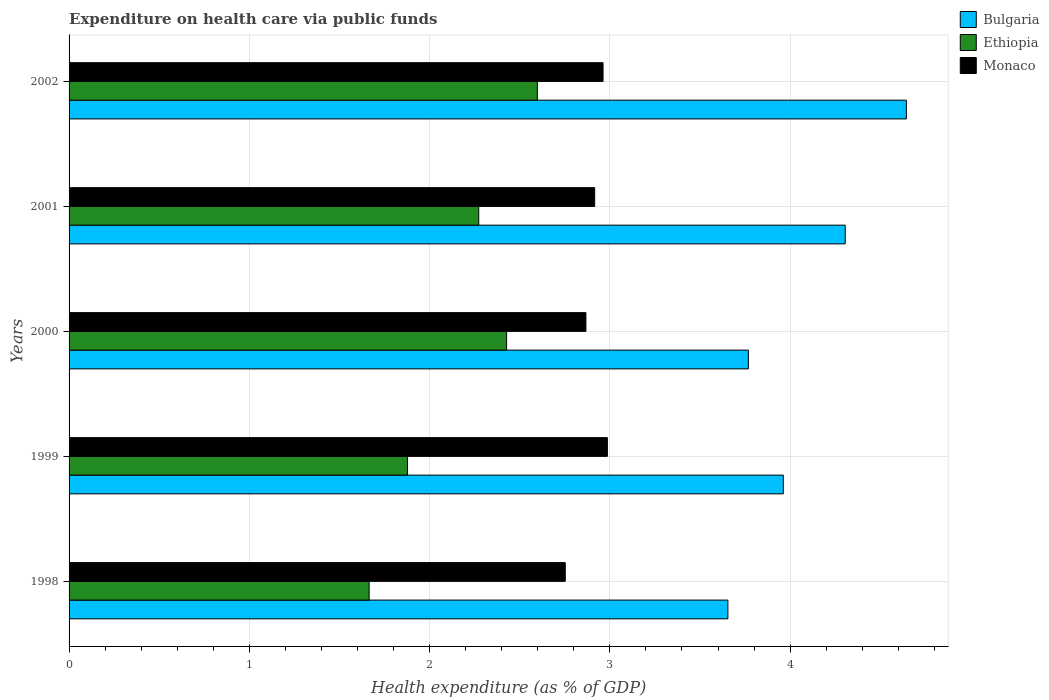How many groups of bars are there?
Offer a terse response. 5. Are the number of bars per tick equal to the number of legend labels?
Offer a terse response. Yes. Are the number of bars on each tick of the Y-axis equal?
Your response must be concise. Yes. How many bars are there on the 3rd tick from the top?
Ensure brevity in your answer.  3. In how many cases, is the number of bars for a given year not equal to the number of legend labels?
Give a very brief answer. 0. What is the expenditure made on health care in Ethiopia in 2002?
Provide a short and direct response. 2.6. Across all years, what is the maximum expenditure made on health care in Monaco?
Offer a very short reply. 2.99. Across all years, what is the minimum expenditure made on health care in Bulgaria?
Offer a terse response. 3.65. In which year was the expenditure made on health care in Bulgaria maximum?
Your response must be concise. 2002. In which year was the expenditure made on health care in Monaco minimum?
Provide a succinct answer. 1998. What is the total expenditure made on health care in Monaco in the graph?
Offer a very short reply. 14.48. What is the difference between the expenditure made on health care in Bulgaria in 2000 and that in 2001?
Your response must be concise. -0.54. What is the difference between the expenditure made on health care in Bulgaria in 2001 and the expenditure made on health care in Ethiopia in 2002?
Make the answer very short. 1.71. What is the average expenditure made on health care in Ethiopia per year?
Your answer should be very brief. 2.17. In the year 1999, what is the difference between the expenditure made on health care in Monaco and expenditure made on health care in Ethiopia?
Give a very brief answer. 1.11. What is the ratio of the expenditure made on health care in Ethiopia in 1998 to that in 2001?
Your answer should be compact. 0.73. Is the expenditure made on health care in Ethiopia in 1998 less than that in 1999?
Keep it short and to the point. Yes. What is the difference between the highest and the second highest expenditure made on health care in Monaco?
Keep it short and to the point. 0.02. What is the difference between the highest and the lowest expenditure made on health care in Bulgaria?
Provide a short and direct response. 0.99. In how many years, is the expenditure made on health care in Monaco greater than the average expenditure made on health care in Monaco taken over all years?
Provide a short and direct response. 3. What does the 1st bar from the top in 2000 represents?
Offer a very short reply. Monaco. What does the 1st bar from the bottom in 1998 represents?
Your response must be concise. Bulgaria. Are all the bars in the graph horizontal?
Offer a very short reply. Yes. Are the values on the major ticks of X-axis written in scientific E-notation?
Keep it short and to the point. No. Does the graph contain any zero values?
Offer a very short reply. No. Where does the legend appear in the graph?
Provide a succinct answer. Top right. What is the title of the graph?
Keep it short and to the point. Expenditure on health care via public funds. Does "Lao PDR" appear as one of the legend labels in the graph?
Your answer should be very brief. No. What is the label or title of the X-axis?
Keep it short and to the point. Health expenditure (as % of GDP). What is the label or title of the Y-axis?
Keep it short and to the point. Years. What is the Health expenditure (as % of GDP) in Bulgaria in 1998?
Make the answer very short. 3.65. What is the Health expenditure (as % of GDP) of Ethiopia in 1998?
Ensure brevity in your answer.  1.66. What is the Health expenditure (as % of GDP) in Monaco in 1998?
Your answer should be compact. 2.75. What is the Health expenditure (as % of GDP) of Bulgaria in 1999?
Your response must be concise. 3.96. What is the Health expenditure (as % of GDP) of Ethiopia in 1999?
Make the answer very short. 1.88. What is the Health expenditure (as % of GDP) in Monaco in 1999?
Ensure brevity in your answer.  2.99. What is the Health expenditure (as % of GDP) in Bulgaria in 2000?
Ensure brevity in your answer.  3.77. What is the Health expenditure (as % of GDP) in Ethiopia in 2000?
Your answer should be compact. 2.43. What is the Health expenditure (as % of GDP) of Monaco in 2000?
Your answer should be compact. 2.87. What is the Health expenditure (as % of GDP) of Bulgaria in 2001?
Your answer should be compact. 4.31. What is the Health expenditure (as % of GDP) of Ethiopia in 2001?
Provide a succinct answer. 2.27. What is the Health expenditure (as % of GDP) of Monaco in 2001?
Make the answer very short. 2.92. What is the Health expenditure (as % of GDP) in Bulgaria in 2002?
Keep it short and to the point. 4.65. What is the Health expenditure (as % of GDP) of Ethiopia in 2002?
Your answer should be very brief. 2.6. What is the Health expenditure (as % of GDP) of Monaco in 2002?
Give a very brief answer. 2.96. Across all years, what is the maximum Health expenditure (as % of GDP) of Bulgaria?
Keep it short and to the point. 4.65. Across all years, what is the maximum Health expenditure (as % of GDP) of Ethiopia?
Offer a very short reply. 2.6. Across all years, what is the maximum Health expenditure (as % of GDP) of Monaco?
Your answer should be very brief. 2.99. Across all years, what is the minimum Health expenditure (as % of GDP) in Bulgaria?
Offer a very short reply. 3.65. Across all years, what is the minimum Health expenditure (as % of GDP) in Ethiopia?
Make the answer very short. 1.66. Across all years, what is the minimum Health expenditure (as % of GDP) in Monaco?
Your answer should be very brief. 2.75. What is the total Health expenditure (as % of GDP) in Bulgaria in the graph?
Make the answer very short. 20.34. What is the total Health expenditure (as % of GDP) in Ethiopia in the graph?
Your answer should be very brief. 10.84. What is the total Health expenditure (as % of GDP) in Monaco in the graph?
Make the answer very short. 14.48. What is the difference between the Health expenditure (as % of GDP) in Bulgaria in 1998 and that in 1999?
Provide a succinct answer. -0.31. What is the difference between the Health expenditure (as % of GDP) in Ethiopia in 1998 and that in 1999?
Provide a succinct answer. -0.21. What is the difference between the Health expenditure (as % of GDP) in Monaco in 1998 and that in 1999?
Provide a succinct answer. -0.23. What is the difference between the Health expenditure (as % of GDP) in Bulgaria in 1998 and that in 2000?
Offer a very short reply. -0.11. What is the difference between the Health expenditure (as % of GDP) of Ethiopia in 1998 and that in 2000?
Your answer should be very brief. -0.76. What is the difference between the Health expenditure (as % of GDP) of Monaco in 1998 and that in 2000?
Your answer should be very brief. -0.11. What is the difference between the Health expenditure (as % of GDP) in Bulgaria in 1998 and that in 2001?
Offer a terse response. -0.65. What is the difference between the Health expenditure (as % of GDP) of Ethiopia in 1998 and that in 2001?
Offer a very short reply. -0.61. What is the difference between the Health expenditure (as % of GDP) in Monaco in 1998 and that in 2001?
Offer a terse response. -0.16. What is the difference between the Health expenditure (as % of GDP) in Bulgaria in 1998 and that in 2002?
Offer a terse response. -0.99. What is the difference between the Health expenditure (as % of GDP) of Ethiopia in 1998 and that in 2002?
Make the answer very short. -0.93. What is the difference between the Health expenditure (as % of GDP) of Monaco in 1998 and that in 2002?
Offer a very short reply. -0.21. What is the difference between the Health expenditure (as % of GDP) of Bulgaria in 1999 and that in 2000?
Give a very brief answer. 0.19. What is the difference between the Health expenditure (as % of GDP) of Ethiopia in 1999 and that in 2000?
Ensure brevity in your answer.  -0.55. What is the difference between the Health expenditure (as % of GDP) of Monaco in 1999 and that in 2000?
Your answer should be very brief. 0.12. What is the difference between the Health expenditure (as % of GDP) in Bulgaria in 1999 and that in 2001?
Offer a very short reply. -0.34. What is the difference between the Health expenditure (as % of GDP) in Ethiopia in 1999 and that in 2001?
Provide a succinct answer. -0.4. What is the difference between the Health expenditure (as % of GDP) of Monaco in 1999 and that in 2001?
Your answer should be compact. 0.07. What is the difference between the Health expenditure (as % of GDP) of Bulgaria in 1999 and that in 2002?
Provide a short and direct response. -0.68. What is the difference between the Health expenditure (as % of GDP) in Ethiopia in 1999 and that in 2002?
Your answer should be compact. -0.72. What is the difference between the Health expenditure (as % of GDP) of Monaco in 1999 and that in 2002?
Ensure brevity in your answer.  0.02. What is the difference between the Health expenditure (as % of GDP) of Bulgaria in 2000 and that in 2001?
Provide a short and direct response. -0.54. What is the difference between the Health expenditure (as % of GDP) in Ethiopia in 2000 and that in 2001?
Provide a short and direct response. 0.15. What is the difference between the Health expenditure (as % of GDP) of Monaco in 2000 and that in 2001?
Your answer should be compact. -0.05. What is the difference between the Health expenditure (as % of GDP) in Bulgaria in 2000 and that in 2002?
Your answer should be compact. -0.88. What is the difference between the Health expenditure (as % of GDP) of Ethiopia in 2000 and that in 2002?
Your response must be concise. -0.17. What is the difference between the Health expenditure (as % of GDP) in Monaco in 2000 and that in 2002?
Give a very brief answer. -0.1. What is the difference between the Health expenditure (as % of GDP) of Bulgaria in 2001 and that in 2002?
Your answer should be very brief. -0.34. What is the difference between the Health expenditure (as % of GDP) in Ethiopia in 2001 and that in 2002?
Offer a terse response. -0.33. What is the difference between the Health expenditure (as % of GDP) of Monaco in 2001 and that in 2002?
Make the answer very short. -0.05. What is the difference between the Health expenditure (as % of GDP) in Bulgaria in 1998 and the Health expenditure (as % of GDP) in Ethiopia in 1999?
Give a very brief answer. 1.78. What is the difference between the Health expenditure (as % of GDP) of Bulgaria in 1998 and the Health expenditure (as % of GDP) of Monaco in 1999?
Keep it short and to the point. 0.67. What is the difference between the Health expenditure (as % of GDP) of Ethiopia in 1998 and the Health expenditure (as % of GDP) of Monaco in 1999?
Your response must be concise. -1.32. What is the difference between the Health expenditure (as % of GDP) of Bulgaria in 1998 and the Health expenditure (as % of GDP) of Ethiopia in 2000?
Make the answer very short. 1.23. What is the difference between the Health expenditure (as % of GDP) in Bulgaria in 1998 and the Health expenditure (as % of GDP) in Monaco in 2000?
Your answer should be compact. 0.79. What is the difference between the Health expenditure (as % of GDP) of Ethiopia in 1998 and the Health expenditure (as % of GDP) of Monaco in 2000?
Your response must be concise. -1.2. What is the difference between the Health expenditure (as % of GDP) in Bulgaria in 1998 and the Health expenditure (as % of GDP) in Ethiopia in 2001?
Ensure brevity in your answer.  1.38. What is the difference between the Health expenditure (as % of GDP) of Bulgaria in 1998 and the Health expenditure (as % of GDP) of Monaco in 2001?
Your answer should be very brief. 0.74. What is the difference between the Health expenditure (as % of GDP) in Ethiopia in 1998 and the Health expenditure (as % of GDP) in Monaco in 2001?
Provide a succinct answer. -1.25. What is the difference between the Health expenditure (as % of GDP) of Bulgaria in 1998 and the Health expenditure (as % of GDP) of Ethiopia in 2002?
Your answer should be very brief. 1.06. What is the difference between the Health expenditure (as % of GDP) in Bulgaria in 1998 and the Health expenditure (as % of GDP) in Monaco in 2002?
Make the answer very short. 0.69. What is the difference between the Health expenditure (as % of GDP) in Ethiopia in 1998 and the Health expenditure (as % of GDP) in Monaco in 2002?
Offer a very short reply. -1.3. What is the difference between the Health expenditure (as % of GDP) of Bulgaria in 1999 and the Health expenditure (as % of GDP) of Ethiopia in 2000?
Keep it short and to the point. 1.54. What is the difference between the Health expenditure (as % of GDP) of Bulgaria in 1999 and the Health expenditure (as % of GDP) of Monaco in 2000?
Your answer should be very brief. 1.1. What is the difference between the Health expenditure (as % of GDP) in Ethiopia in 1999 and the Health expenditure (as % of GDP) in Monaco in 2000?
Your response must be concise. -0.99. What is the difference between the Health expenditure (as % of GDP) in Bulgaria in 1999 and the Health expenditure (as % of GDP) in Ethiopia in 2001?
Make the answer very short. 1.69. What is the difference between the Health expenditure (as % of GDP) in Bulgaria in 1999 and the Health expenditure (as % of GDP) in Monaco in 2001?
Offer a very short reply. 1.05. What is the difference between the Health expenditure (as % of GDP) of Ethiopia in 1999 and the Health expenditure (as % of GDP) of Monaco in 2001?
Your answer should be compact. -1.04. What is the difference between the Health expenditure (as % of GDP) in Bulgaria in 1999 and the Health expenditure (as % of GDP) in Ethiopia in 2002?
Your answer should be very brief. 1.36. What is the difference between the Health expenditure (as % of GDP) in Ethiopia in 1999 and the Health expenditure (as % of GDP) in Monaco in 2002?
Your answer should be compact. -1.08. What is the difference between the Health expenditure (as % of GDP) in Bulgaria in 2000 and the Health expenditure (as % of GDP) in Ethiopia in 2001?
Make the answer very short. 1.5. What is the difference between the Health expenditure (as % of GDP) of Bulgaria in 2000 and the Health expenditure (as % of GDP) of Monaco in 2001?
Offer a very short reply. 0.85. What is the difference between the Health expenditure (as % of GDP) in Ethiopia in 2000 and the Health expenditure (as % of GDP) in Monaco in 2001?
Give a very brief answer. -0.49. What is the difference between the Health expenditure (as % of GDP) of Bulgaria in 2000 and the Health expenditure (as % of GDP) of Ethiopia in 2002?
Your answer should be compact. 1.17. What is the difference between the Health expenditure (as % of GDP) of Bulgaria in 2000 and the Health expenditure (as % of GDP) of Monaco in 2002?
Your answer should be compact. 0.81. What is the difference between the Health expenditure (as % of GDP) of Ethiopia in 2000 and the Health expenditure (as % of GDP) of Monaco in 2002?
Offer a very short reply. -0.54. What is the difference between the Health expenditure (as % of GDP) of Bulgaria in 2001 and the Health expenditure (as % of GDP) of Ethiopia in 2002?
Offer a very short reply. 1.71. What is the difference between the Health expenditure (as % of GDP) of Bulgaria in 2001 and the Health expenditure (as % of GDP) of Monaco in 2002?
Give a very brief answer. 1.34. What is the difference between the Health expenditure (as % of GDP) of Ethiopia in 2001 and the Health expenditure (as % of GDP) of Monaco in 2002?
Keep it short and to the point. -0.69. What is the average Health expenditure (as % of GDP) of Bulgaria per year?
Provide a succinct answer. 4.07. What is the average Health expenditure (as % of GDP) of Ethiopia per year?
Provide a succinct answer. 2.17. What is the average Health expenditure (as % of GDP) in Monaco per year?
Provide a short and direct response. 2.9. In the year 1998, what is the difference between the Health expenditure (as % of GDP) in Bulgaria and Health expenditure (as % of GDP) in Ethiopia?
Your answer should be compact. 1.99. In the year 1998, what is the difference between the Health expenditure (as % of GDP) of Bulgaria and Health expenditure (as % of GDP) of Monaco?
Make the answer very short. 0.9. In the year 1998, what is the difference between the Health expenditure (as % of GDP) of Ethiopia and Health expenditure (as % of GDP) of Monaco?
Make the answer very short. -1.09. In the year 1999, what is the difference between the Health expenditure (as % of GDP) in Bulgaria and Health expenditure (as % of GDP) in Ethiopia?
Provide a short and direct response. 2.09. In the year 1999, what is the difference between the Health expenditure (as % of GDP) in Bulgaria and Health expenditure (as % of GDP) in Monaco?
Your answer should be compact. 0.98. In the year 1999, what is the difference between the Health expenditure (as % of GDP) of Ethiopia and Health expenditure (as % of GDP) of Monaco?
Provide a short and direct response. -1.11. In the year 2000, what is the difference between the Health expenditure (as % of GDP) in Bulgaria and Health expenditure (as % of GDP) in Ethiopia?
Offer a very short reply. 1.34. In the year 2000, what is the difference between the Health expenditure (as % of GDP) in Bulgaria and Health expenditure (as % of GDP) in Monaco?
Provide a succinct answer. 0.9. In the year 2000, what is the difference between the Health expenditure (as % of GDP) in Ethiopia and Health expenditure (as % of GDP) in Monaco?
Give a very brief answer. -0.44. In the year 2001, what is the difference between the Health expenditure (as % of GDP) of Bulgaria and Health expenditure (as % of GDP) of Ethiopia?
Keep it short and to the point. 2.03. In the year 2001, what is the difference between the Health expenditure (as % of GDP) of Bulgaria and Health expenditure (as % of GDP) of Monaco?
Your response must be concise. 1.39. In the year 2001, what is the difference between the Health expenditure (as % of GDP) in Ethiopia and Health expenditure (as % of GDP) in Monaco?
Give a very brief answer. -0.64. In the year 2002, what is the difference between the Health expenditure (as % of GDP) in Bulgaria and Health expenditure (as % of GDP) in Ethiopia?
Offer a terse response. 2.05. In the year 2002, what is the difference between the Health expenditure (as % of GDP) of Bulgaria and Health expenditure (as % of GDP) of Monaco?
Provide a succinct answer. 1.68. In the year 2002, what is the difference between the Health expenditure (as % of GDP) of Ethiopia and Health expenditure (as % of GDP) of Monaco?
Ensure brevity in your answer.  -0.36. What is the ratio of the Health expenditure (as % of GDP) in Bulgaria in 1998 to that in 1999?
Offer a very short reply. 0.92. What is the ratio of the Health expenditure (as % of GDP) of Ethiopia in 1998 to that in 1999?
Make the answer very short. 0.89. What is the ratio of the Health expenditure (as % of GDP) of Monaco in 1998 to that in 1999?
Your answer should be compact. 0.92. What is the ratio of the Health expenditure (as % of GDP) in Bulgaria in 1998 to that in 2000?
Give a very brief answer. 0.97. What is the ratio of the Health expenditure (as % of GDP) in Ethiopia in 1998 to that in 2000?
Make the answer very short. 0.69. What is the ratio of the Health expenditure (as % of GDP) of Monaco in 1998 to that in 2000?
Give a very brief answer. 0.96. What is the ratio of the Health expenditure (as % of GDP) of Bulgaria in 1998 to that in 2001?
Your answer should be very brief. 0.85. What is the ratio of the Health expenditure (as % of GDP) in Ethiopia in 1998 to that in 2001?
Provide a short and direct response. 0.73. What is the ratio of the Health expenditure (as % of GDP) of Monaco in 1998 to that in 2001?
Offer a terse response. 0.94. What is the ratio of the Health expenditure (as % of GDP) in Bulgaria in 1998 to that in 2002?
Give a very brief answer. 0.79. What is the ratio of the Health expenditure (as % of GDP) of Ethiopia in 1998 to that in 2002?
Offer a very short reply. 0.64. What is the ratio of the Health expenditure (as % of GDP) of Monaco in 1998 to that in 2002?
Ensure brevity in your answer.  0.93. What is the ratio of the Health expenditure (as % of GDP) in Bulgaria in 1999 to that in 2000?
Your response must be concise. 1.05. What is the ratio of the Health expenditure (as % of GDP) in Ethiopia in 1999 to that in 2000?
Ensure brevity in your answer.  0.77. What is the ratio of the Health expenditure (as % of GDP) in Monaco in 1999 to that in 2000?
Your response must be concise. 1.04. What is the ratio of the Health expenditure (as % of GDP) in Bulgaria in 1999 to that in 2001?
Ensure brevity in your answer.  0.92. What is the ratio of the Health expenditure (as % of GDP) of Ethiopia in 1999 to that in 2001?
Offer a very short reply. 0.83. What is the ratio of the Health expenditure (as % of GDP) of Monaco in 1999 to that in 2001?
Provide a short and direct response. 1.02. What is the ratio of the Health expenditure (as % of GDP) of Bulgaria in 1999 to that in 2002?
Provide a short and direct response. 0.85. What is the ratio of the Health expenditure (as % of GDP) of Ethiopia in 1999 to that in 2002?
Your response must be concise. 0.72. What is the ratio of the Health expenditure (as % of GDP) in Monaco in 1999 to that in 2002?
Offer a very short reply. 1.01. What is the ratio of the Health expenditure (as % of GDP) in Bulgaria in 2000 to that in 2001?
Keep it short and to the point. 0.88. What is the ratio of the Health expenditure (as % of GDP) of Ethiopia in 2000 to that in 2001?
Give a very brief answer. 1.07. What is the ratio of the Health expenditure (as % of GDP) in Monaco in 2000 to that in 2001?
Provide a succinct answer. 0.98. What is the ratio of the Health expenditure (as % of GDP) in Bulgaria in 2000 to that in 2002?
Offer a terse response. 0.81. What is the ratio of the Health expenditure (as % of GDP) of Ethiopia in 2000 to that in 2002?
Offer a very short reply. 0.93. What is the ratio of the Health expenditure (as % of GDP) in Monaco in 2000 to that in 2002?
Your response must be concise. 0.97. What is the ratio of the Health expenditure (as % of GDP) in Bulgaria in 2001 to that in 2002?
Ensure brevity in your answer.  0.93. What is the ratio of the Health expenditure (as % of GDP) in Ethiopia in 2001 to that in 2002?
Make the answer very short. 0.87. What is the ratio of the Health expenditure (as % of GDP) in Monaco in 2001 to that in 2002?
Keep it short and to the point. 0.98. What is the difference between the highest and the second highest Health expenditure (as % of GDP) in Bulgaria?
Offer a terse response. 0.34. What is the difference between the highest and the second highest Health expenditure (as % of GDP) of Ethiopia?
Ensure brevity in your answer.  0.17. What is the difference between the highest and the second highest Health expenditure (as % of GDP) in Monaco?
Ensure brevity in your answer.  0.02. What is the difference between the highest and the lowest Health expenditure (as % of GDP) of Bulgaria?
Provide a short and direct response. 0.99. What is the difference between the highest and the lowest Health expenditure (as % of GDP) in Ethiopia?
Your answer should be very brief. 0.93. What is the difference between the highest and the lowest Health expenditure (as % of GDP) in Monaco?
Give a very brief answer. 0.23. 